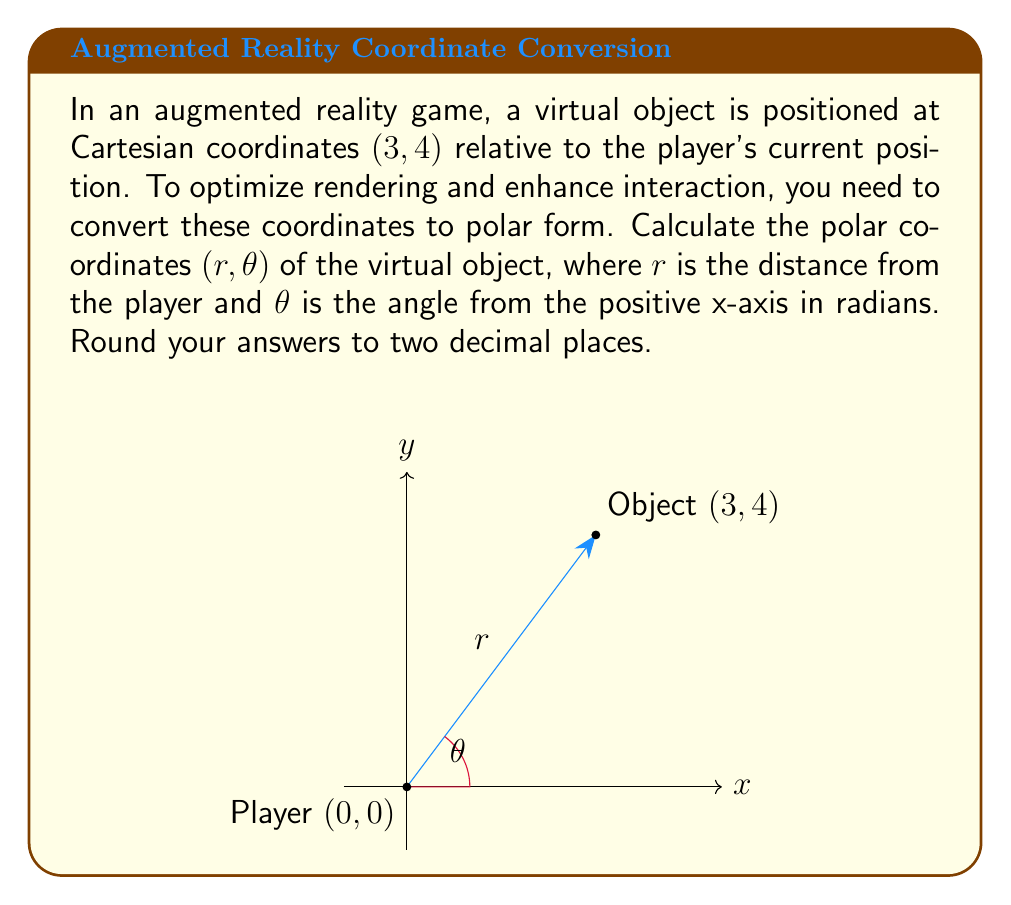Show me your answer to this math problem. To convert from Cartesian coordinates (x, y) to polar coordinates (r, θ), we use the following formulas:

1. For r (distance): 
   $$r = \sqrt{x^2 + y^2}$$

2. For θ (angle):
   $$\theta = \tan^{-1}\left(\frac{y}{x}\right)$$

Let's solve this step-by-step:

1. Calculate r:
   $$r = \sqrt{3^2 + 4^2} = \sqrt{9 + 16} = \sqrt{25} = 5$$

2. Calculate θ:
   $$\theta = \tan^{-1}\left(\frac{4}{3}\right) \approx 0.9273 \text{ radians}$$

3. Round both values to two decimal places:
   r ≈ 5.00 (already in two decimal places)
   θ ≈ 0.93 radians

Therefore, the polar coordinates of the virtual object are approximately (5.00, 0.93).
Answer: (5.00, 0.93) 